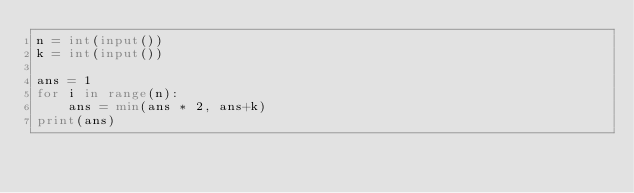<code> <loc_0><loc_0><loc_500><loc_500><_Python_>n = int(input())
k = int(input())

ans = 1
for i in range(n):
    ans = min(ans * 2, ans+k)
print(ans)
</code> 